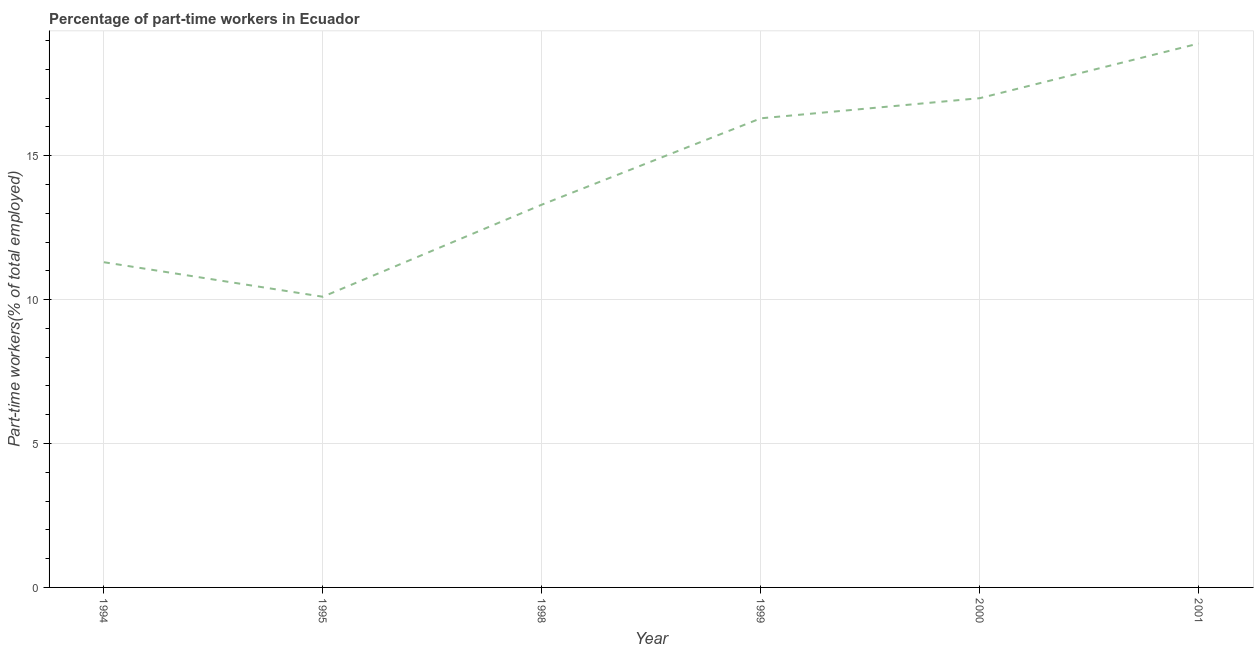What is the percentage of part-time workers in 1998?
Your answer should be compact. 13.3. Across all years, what is the maximum percentage of part-time workers?
Ensure brevity in your answer.  18.9. Across all years, what is the minimum percentage of part-time workers?
Give a very brief answer. 10.1. In which year was the percentage of part-time workers maximum?
Your answer should be compact. 2001. In which year was the percentage of part-time workers minimum?
Offer a terse response. 1995. What is the sum of the percentage of part-time workers?
Your response must be concise. 86.9. What is the difference between the percentage of part-time workers in 1999 and 2001?
Your answer should be compact. -2.6. What is the average percentage of part-time workers per year?
Give a very brief answer. 14.48. What is the median percentage of part-time workers?
Offer a very short reply. 14.8. In how many years, is the percentage of part-time workers greater than 8 %?
Give a very brief answer. 6. Do a majority of the years between 1995 and 1994 (inclusive) have percentage of part-time workers greater than 3 %?
Ensure brevity in your answer.  No. What is the ratio of the percentage of part-time workers in 1998 to that in 2000?
Offer a terse response. 0.78. Is the percentage of part-time workers in 2000 less than that in 2001?
Ensure brevity in your answer.  Yes. Is the difference between the percentage of part-time workers in 1995 and 1998 greater than the difference between any two years?
Make the answer very short. No. What is the difference between the highest and the second highest percentage of part-time workers?
Provide a short and direct response. 1.9. What is the difference between the highest and the lowest percentage of part-time workers?
Offer a very short reply. 8.8. In how many years, is the percentage of part-time workers greater than the average percentage of part-time workers taken over all years?
Your answer should be compact. 3. Does the percentage of part-time workers monotonically increase over the years?
Ensure brevity in your answer.  No. How many lines are there?
Make the answer very short. 1. How many years are there in the graph?
Ensure brevity in your answer.  6. Does the graph contain any zero values?
Offer a terse response. No. What is the title of the graph?
Make the answer very short. Percentage of part-time workers in Ecuador. What is the label or title of the X-axis?
Give a very brief answer. Year. What is the label or title of the Y-axis?
Offer a very short reply. Part-time workers(% of total employed). What is the Part-time workers(% of total employed) in 1994?
Offer a very short reply. 11.3. What is the Part-time workers(% of total employed) of 1995?
Your answer should be compact. 10.1. What is the Part-time workers(% of total employed) in 1998?
Provide a short and direct response. 13.3. What is the Part-time workers(% of total employed) in 1999?
Your answer should be compact. 16.3. What is the Part-time workers(% of total employed) in 2000?
Provide a succinct answer. 17. What is the Part-time workers(% of total employed) in 2001?
Keep it short and to the point. 18.9. What is the difference between the Part-time workers(% of total employed) in 1994 and 1995?
Make the answer very short. 1.2. What is the difference between the Part-time workers(% of total employed) in 1994 and 1998?
Your response must be concise. -2. What is the difference between the Part-time workers(% of total employed) in 1994 and 2000?
Provide a succinct answer. -5.7. What is the difference between the Part-time workers(% of total employed) in 1995 and 2001?
Make the answer very short. -8.8. What is the difference between the Part-time workers(% of total employed) in 1998 and 2000?
Provide a succinct answer. -3.7. What is the difference between the Part-time workers(% of total employed) in 1998 and 2001?
Offer a very short reply. -5.6. What is the difference between the Part-time workers(% of total employed) in 1999 and 2000?
Your answer should be compact. -0.7. What is the difference between the Part-time workers(% of total employed) in 2000 and 2001?
Offer a terse response. -1.9. What is the ratio of the Part-time workers(% of total employed) in 1994 to that in 1995?
Ensure brevity in your answer.  1.12. What is the ratio of the Part-time workers(% of total employed) in 1994 to that in 1998?
Your answer should be compact. 0.85. What is the ratio of the Part-time workers(% of total employed) in 1994 to that in 1999?
Give a very brief answer. 0.69. What is the ratio of the Part-time workers(% of total employed) in 1994 to that in 2000?
Provide a short and direct response. 0.67. What is the ratio of the Part-time workers(% of total employed) in 1994 to that in 2001?
Offer a terse response. 0.6. What is the ratio of the Part-time workers(% of total employed) in 1995 to that in 1998?
Offer a very short reply. 0.76. What is the ratio of the Part-time workers(% of total employed) in 1995 to that in 1999?
Offer a terse response. 0.62. What is the ratio of the Part-time workers(% of total employed) in 1995 to that in 2000?
Offer a terse response. 0.59. What is the ratio of the Part-time workers(% of total employed) in 1995 to that in 2001?
Offer a very short reply. 0.53. What is the ratio of the Part-time workers(% of total employed) in 1998 to that in 1999?
Your response must be concise. 0.82. What is the ratio of the Part-time workers(% of total employed) in 1998 to that in 2000?
Your answer should be compact. 0.78. What is the ratio of the Part-time workers(% of total employed) in 1998 to that in 2001?
Offer a very short reply. 0.7. What is the ratio of the Part-time workers(% of total employed) in 1999 to that in 2001?
Your response must be concise. 0.86. What is the ratio of the Part-time workers(% of total employed) in 2000 to that in 2001?
Provide a succinct answer. 0.9. 